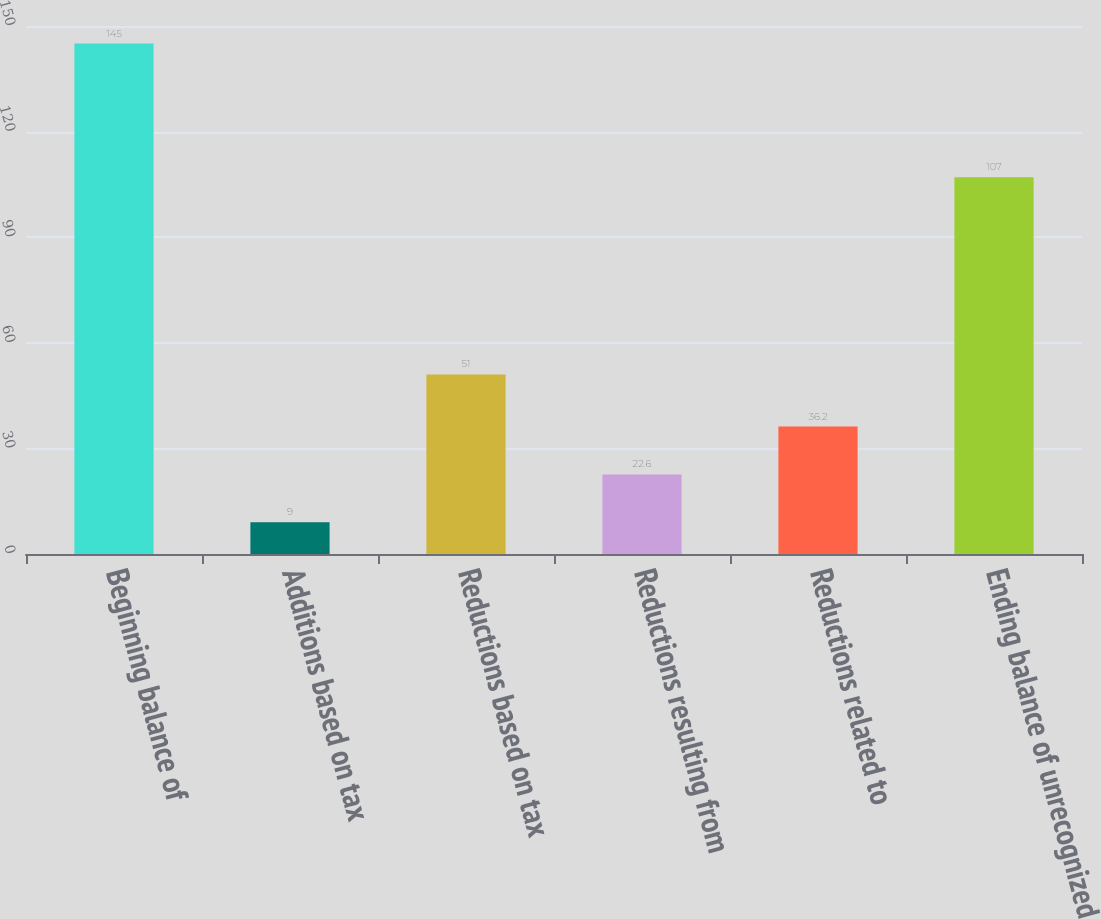Convert chart. <chart><loc_0><loc_0><loc_500><loc_500><bar_chart><fcel>Beginning balance of<fcel>Additions based on tax<fcel>Reductions based on tax<fcel>Reductions resulting from<fcel>Reductions related to<fcel>Ending balance of unrecognized<nl><fcel>145<fcel>9<fcel>51<fcel>22.6<fcel>36.2<fcel>107<nl></chart> 